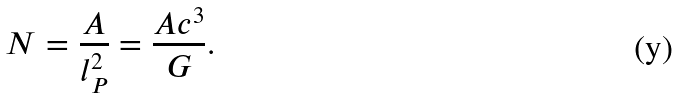Convert formula to latex. <formula><loc_0><loc_0><loc_500><loc_500>N = \frac { A } { l _ { P } ^ { 2 } } = \frac { A c ^ { 3 } } { G } .</formula> 